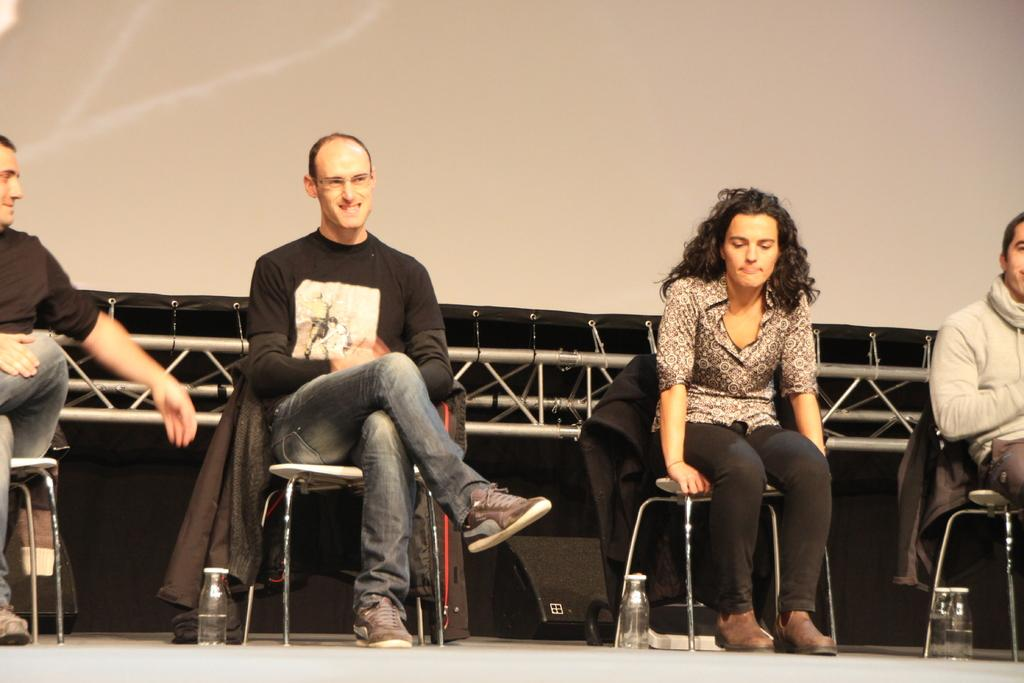Who or what is present in the image? There are people in the image. What are the people doing in the image? The people are sitting. What objects are beside the people? There are bottles beside the people. What can be seen in the background of the image? There are metal rods and a screen in the background of the image. What is the weight of the hot answer in the image? There is no hot answer present in the image, as it does not involve any text or verbal communication. 